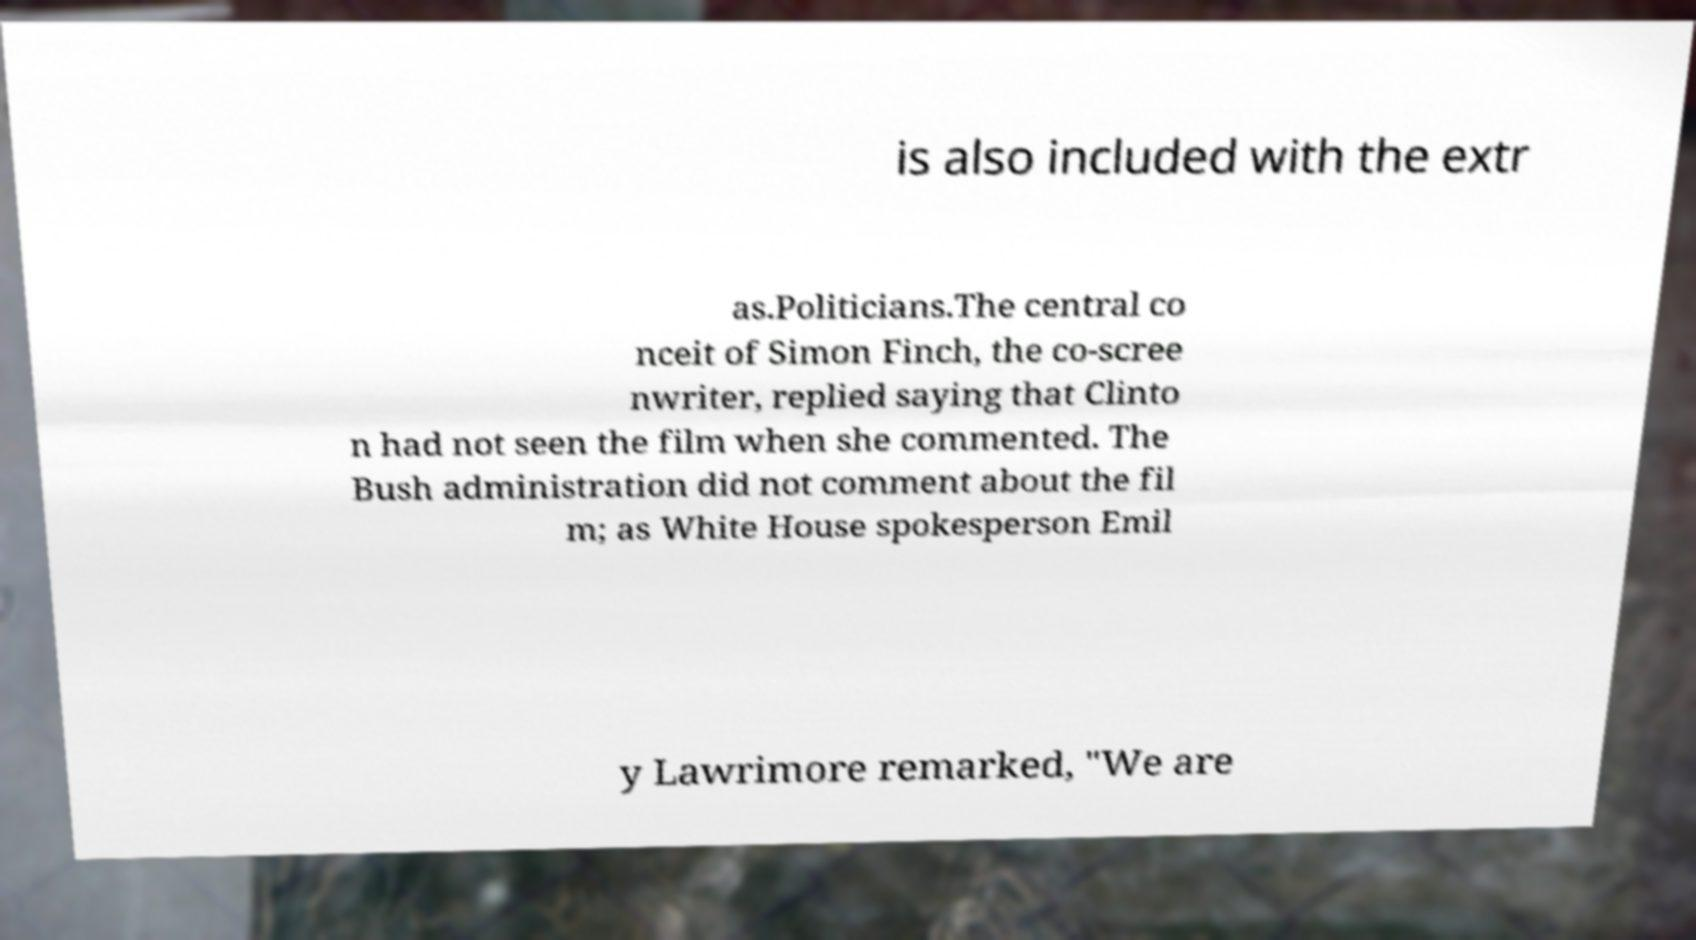Could you assist in decoding the text presented in this image and type it out clearly? is also included with the extr as.Politicians.The central co nceit of Simon Finch, the co-scree nwriter, replied saying that Clinto n had not seen the film when she commented. The Bush administration did not comment about the fil m; as White House spokesperson Emil y Lawrimore remarked, "We are 